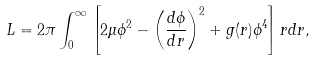Convert formula to latex. <formula><loc_0><loc_0><loc_500><loc_500>L = 2 \pi \int _ { 0 } ^ { \infty } \left [ 2 \mu \phi ^ { 2 } - \left ( \frac { d \phi } { d r } \right ) ^ { 2 } + g ( r ) \phi ^ { 4 } \right ] r d r ,</formula> 